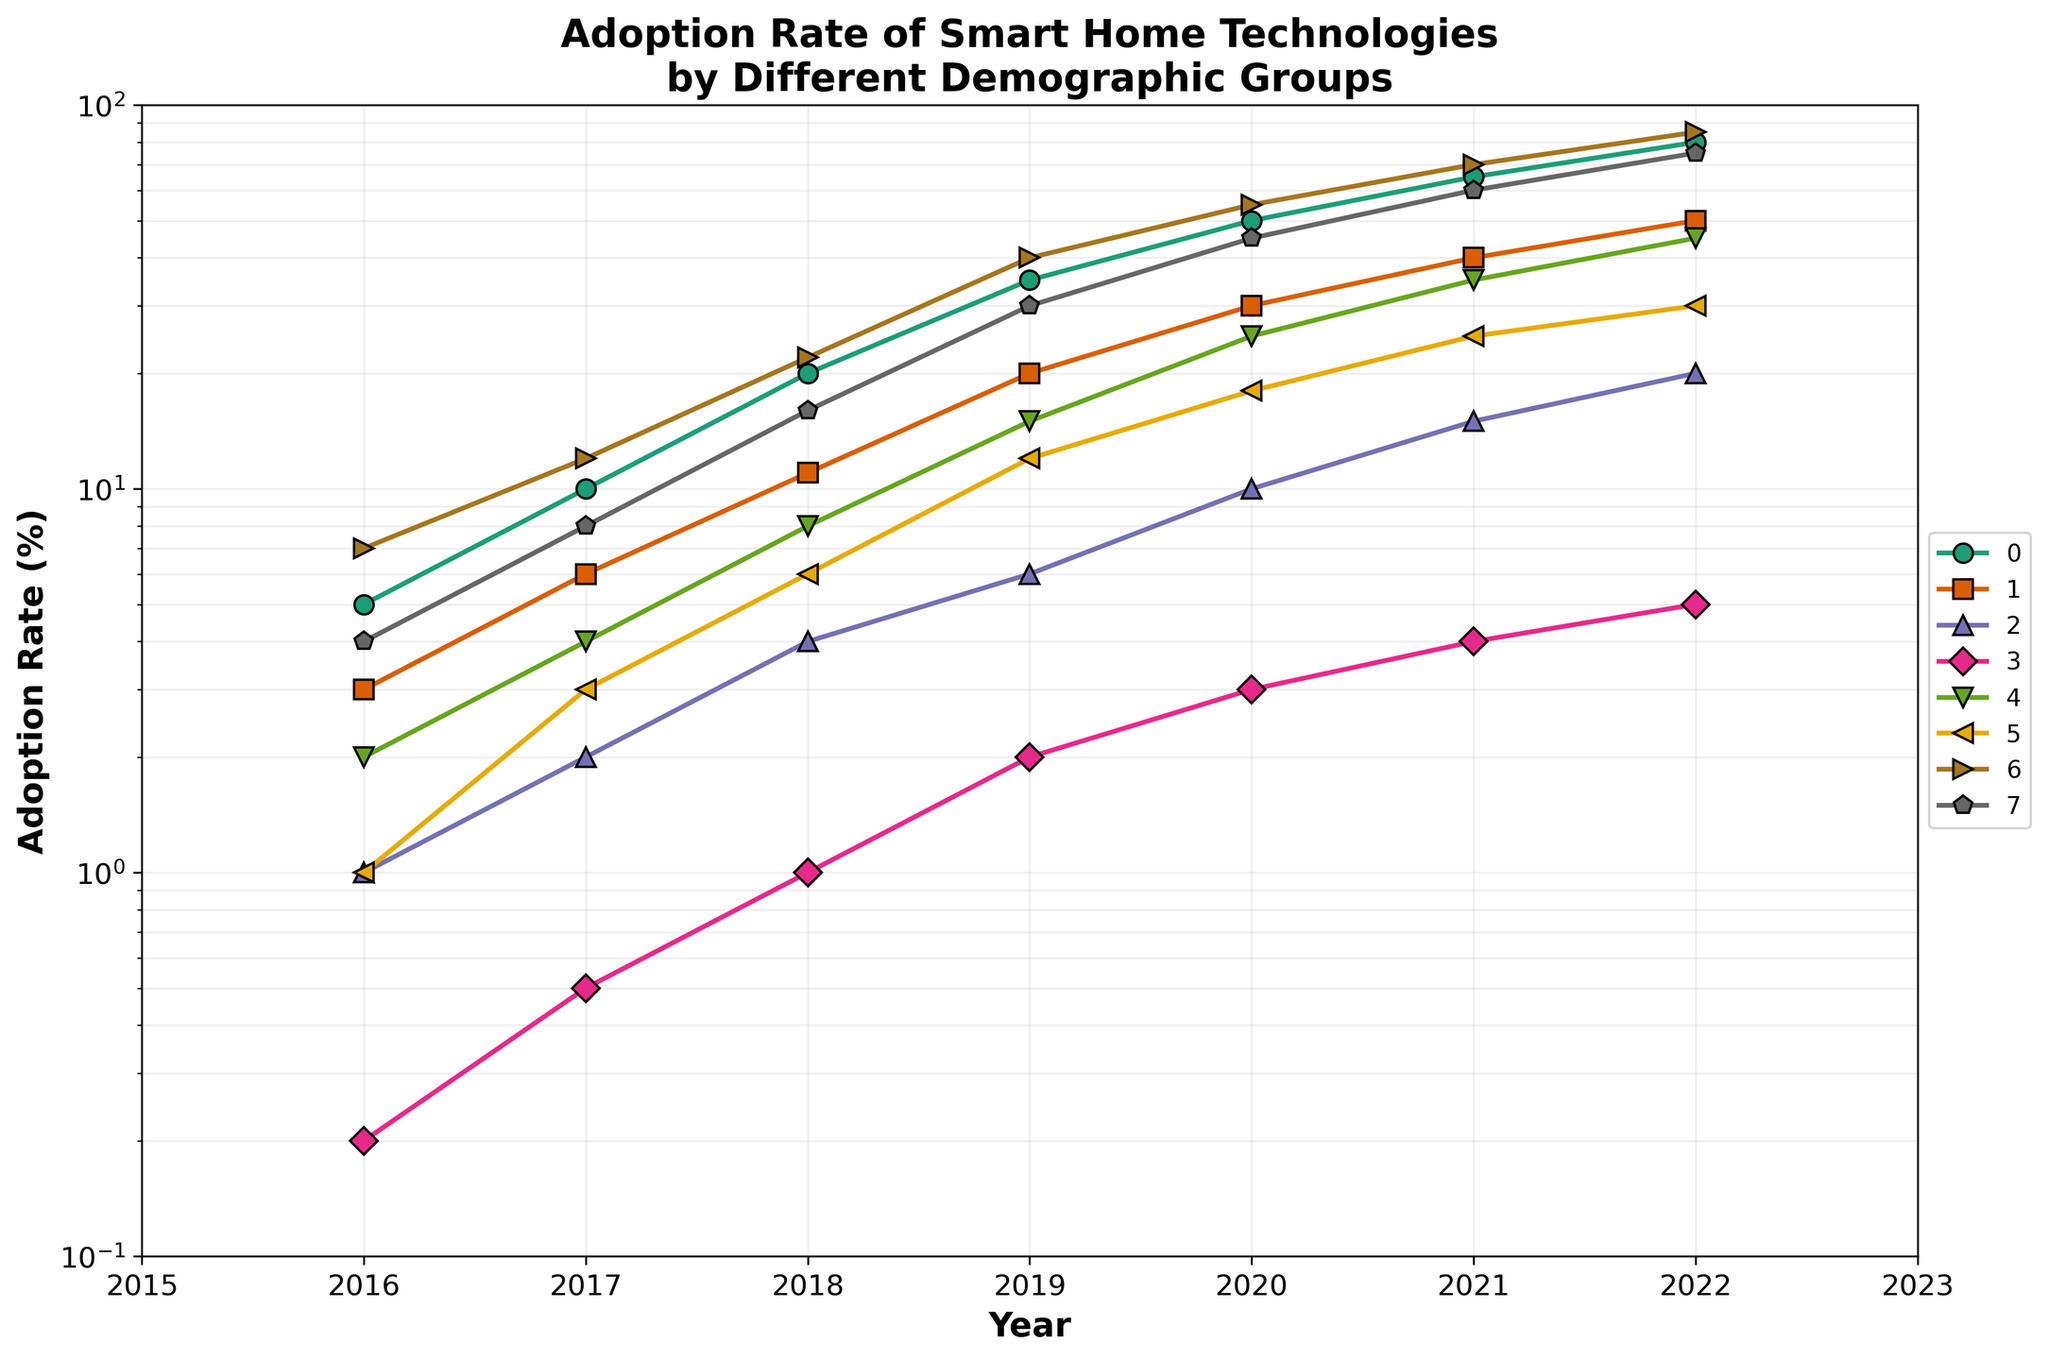What is the title of the figure? The title is always positioned at the top of the figure and often summarizes what the figure is about. Here it reads, "Adoption Rate of Smart Home Technologies by Different Demographic Groups".
Answer: Adoption Rate of Smart Home Technologies by Different Demographic Groups What is the range of the y-axis on the log scale? The y-axis range can be seen by looking at the lowest and highest tick marks on the y-axis. In this figure, it starts from 0.1 and goes up to 100.
Answer: 0.1 to 100 Which demographic group had the highest adoption rate in 2022? By examining the endpoints of the lines for the year 2022 on the x-axis, the line representing Millenials is visibly at the highest y-axis value.
Answer: Millennials How did the adoption rate of Baby Boomers change from 2016 to 2022? Note the starting and ending values of the Baby Boomers line. In 2016, it starts at 1 and increases steadily, reaching 20 in 2022.
Answer: Increased from 1 to 20 Which demographic group shows the steepest growth in adoption rate between 2016 and 2022? Steepest growth on a log scale involves a line with a large rise over a given horizontal interval, indicating multiplicative growth. Compare each line's slope visually; Millennials seem to have the sharpest incline.
Answer: Millennials What is the difference in adoption rate between 'Expatriates in USA' and 'Expatriates in EU' in 2020? Check the corresponding points above 2020 on the x-axis for both lines. Expatriates in USA at 25% and Expatriates in EU at 18%.
Answer: 7% Which group had a slower growth rate, Seniors or Baby Boomers? Compare the adjacency and slope of the lines. Seniors start from 0.2 to 5, while Baby Boomers start from 1 to 20. Seniors have a flatter line indicating slower growth.
Answer: Seniors By how much did the adoption rate of Single Households increase from 2019 to 2021? Identify the points corresponding to 2019 and 2021 for Single Households line. It moved from 40 to 70. Subtract to find the difference.
Answer: 30 Which demographic group has the lowest adoption rate throughout the years? Examine the lines lowest on the y-axis throughout all the years. The Seniors' line stays consistently low compared to others.
Answer: Seniors What is the trend in adoption rate for 'Families with Children' between 2018 and 2020? Follow the 'Families with Children' line from 2018 to 2020. Identify if it rises, falls or remains constant. It shows an increase from approximately 16 to 45.
Answer: Increasing 